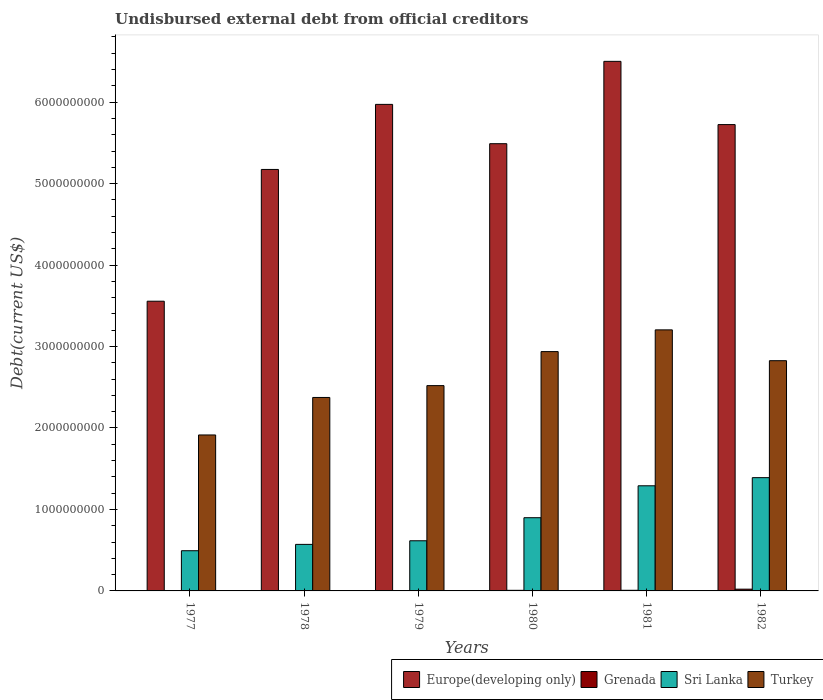How many different coloured bars are there?
Keep it short and to the point. 4. Are the number of bars per tick equal to the number of legend labels?
Make the answer very short. Yes. How many bars are there on the 2nd tick from the left?
Your response must be concise. 4. How many bars are there on the 1st tick from the right?
Your response must be concise. 4. What is the label of the 4th group of bars from the left?
Offer a terse response. 1980. What is the total debt in Grenada in 1979?
Offer a terse response. 1.01e+06. Across all years, what is the maximum total debt in Turkey?
Make the answer very short. 3.20e+09. Across all years, what is the minimum total debt in Europe(developing only)?
Provide a succinct answer. 3.56e+09. In which year was the total debt in Grenada maximum?
Provide a succinct answer. 1982. In which year was the total debt in Europe(developing only) minimum?
Offer a terse response. 1977. What is the total total debt in Europe(developing only) in the graph?
Ensure brevity in your answer.  3.24e+1. What is the difference between the total debt in Turkey in 1978 and that in 1981?
Give a very brief answer. -8.30e+08. What is the difference between the total debt in Grenada in 1981 and the total debt in Turkey in 1982?
Offer a very short reply. -2.82e+09. What is the average total debt in Sri Lanka per year?
Offer a very short reply. 8.77e+08. In the year 1982, what is the difference between the total debt in Turkey and total debt in Europe(developing only)?
Your answer should be compact. -2.90e+09. In how many years, is the total debt in Europe(developing only) greater than 6000000000 US$?
Ensure brevity in your answer.  1. What is the ratio of the total debt in Sri Lanka in 1978 to that in 1982?
Your response must be concise. 0.41. Is the total debt in Sri Lanka in 1978 less than that in 1981?
Keep it short and to the point. Yes. What is the difference between the highest and the second highest total debt in Grenada?
Your answer should be compact. 1.38e+07. What is the difference between the highest and the lowest total debt in Turkey?
Provide a succinct answer. 1.29e+09. In how many years, is the total debt in Sri Lanka greater than the average total debt in Sri Lanka taken over all years?
Provide a succinct answer. 3. Is the sum of the total debt in Sri Lanka in 1977 and 1980 greater than the maximum total debt in Turkey across all years?
Your answer should be very brief. No. What does the 1st bar from the left in 1977 represents?
Offer a very short reply. Europe(developing only). What does the 1st bar from the right in 1977 represents?
Your response must be concise. Turkey. How many bars are there?
Provide a succinct answer. 24. Are all the bars in the graph horizontal?
Your answer should be compact. No. What is the difference between two consecutive major ticks on the Y-axis?
Give a very brief answer. 1.00e+09. Does the graph contain any zero values?
Provide a short and direct response. No. How many legend labels are there?
Ensure brevity in your answer.  4. What is the title of the graph?
Your answer should be compact. Undisbursed external debt from official creditors. What is the label or title of the X-axis?
Offer a terse response. Years. What is the label or title of the Y-axis?
Your answer should be compact. Debt(current US$). What is the Debt(current US$) in Europe(developing only) in 1977?
Give a very brief answer. 3.56e+09. What is the Debt(current US$) in Grenada in 1977?
Make the answer very short. 4.44e+06. What is the Debt(current US$) of Sri Lanka in 1977?
Give a very brief answer. 4.93e+08. What is the Debt(current US$) in Turkey in 1977?
Offer a terse response. 1.91e+09. What is the Debt(current US$) of Europe(developing only) in 1978?
Keep it short and to the point. 5.17e+09. What is the Debt(current US$) of Grenada in 1978?
Offer a terse response. 1.91e+06. What is the Debt(current US$) in Sri Lanka in 1978?
Offer a terse response. 5.71e+08. What is the Debt(current US$) of Turkey in 1978?
Provide a succinct answer. 2.37e+09. What is the Debt(current US$) of Europe(developing only) in 1979?
Offer a very short reply. 5.97e+09. What is the Debt(current US$) in Grenada in 1979?
Provide a short and direct response. 1.01e+06. What is the Debt(current US$) in Sri Lanka in 1979?
Ensure brevity in your answer.  6.16e+08. What is the Debt(current US$) of Turkey in 1979?
Ensure brevity in your answer.  2.52e+09. What is the Debt(current US$) of Europe(developing only) in 1980?
Make the answer very short. 5.49e+09. What is the Debt(current US$) of Grenada in 1980?
Offer a very short reply. 7.29e+06. What is the Debt(current US$) of Sri Lanka in 1980?
Give a very brief answer. 8.99e+08. What is the Debt(current US$) in Turkey in 1980?
Ensure brevity in your answer.  2.94e+09. What is the Debt(current US$) of Europe(developing only) in 1981?
Your answer should be very brief. 6.50e+09. What is the Debt(current US$) of Grenada in 1981?
Provide a succinct answer. 7.84e+06. What is the Debt(current US$) in Sri Lanka in 1981?
Offer a terse response. 1.29e+09. What is the Debt(current US$) in Turkey in 1981?
Give a very brief answer. 3.20e+09. What is the Debt(current US$) of Europe(developing only) in 1982?
Give a very brief answer. 5.72e+09. What is the Debt(current US$) of Grenada in 1982?
Offer a terse response. 2.16e+07. What is the Debt(current US$) in Sri Lanka in 1982?
Offer a terse response. 1.39e+09. What is the Debt(current US$) in Turkey in 1982?
Your answer should be very brief. 2.83e+09. Across all years, what is the maximum Debt(current US$) of Europe(developing only)?
Your response must be concise. 6.50e+09. Across all years, what is the maximum Debt(current US$) of Grenada?
Offer a terse response. 2.16e+07. Across all years, what is the maximum Debt(current US$) in Sri Lanka?
Your answer should be compact. 1.39e+09. Across all years, what is the maximum Debt(current US$) of Turkey?
Provide a succinct answer. 3.20e+09. Across all years, what is the minimum Debt(current US$) in Europe(developing only)?
Your answer should be compact. 3.56e+09. Across all years, what is the minimum Debt(current US$) of Grenada?
Your response must be concise. 1.01e+06. Across all years, what is the minimum Debt(current US$) of Sri Lanka?
Give a very brief answer. 4.93e+08. Across all years, what is the minimum Debt(current US$) in Turkey?
Provide a short and direct response. 1.91e+09. What is the total Debt(current US$) in Europe(developing only) in the graph?
Give a very brief answer. 3.24e+1. What is the total Debt(current US$) in Grenada in the graph?
Your response must be concise. 4.41e+07. What is the total Debt(current US$) in Sri Lanka in the graph?
Keep it short and to the point. 5.26e+09. What is the total Debt(current US$) of Turkey in the graph?
Ensure brevity in your answer.  1.58e+1. What is the difference between the Debt(current US$) in Europe(developing only) in 1977 and that in 1978?
Make the answer very short. -1.62e+09. What is the difference between the Debt(current US$) in Grenada in 1977 and that in 1978?
Keep it short and to the point. 2.53e+06. What is the difference between the Debt(current US$) in Sri Lanka in 1977 and that in 1978?
Ensure brevity in your answer.  -7.78e+07. What is the difference between the Debt(current US$) in Turkey in 1977 and that in 1978?
Your answer should be compact. -4.60e+08. What is the difference between the Debt(current US$) of Europe(developing only) in 1977 and that in 1979?
Make the answer very short. -2.42e+09. What is the difference between the Debt(current US$) in Grenada in 1977 and that in 1979?
Provide a succinct answer. 3.43e+06. What is the difference between the Debt(current US$) in Sri Lanka in 1977 and that in 1979?
Your response must be concise. -1.22e+08. What is the difference between the Debt(current US$) of Turkey in 1977 and that in 1979?
Make the answer very short. -6.06e+08. What is the difference between the Debt(current US$) in Europe(developing only) in 1977 and that in 1980?
Make the answer very short. -1.93e+09. What is the difference between the Debt(current US$) of Grenada in 1977 and that in 1980?
Make the answer very short. -2.85e+06. What is the difference between the Debt(current US$) in Sri Lanka in 1977 and that in 1980?
Give a very brief answer. -4.05e+08. What is the difference between the Debt(current US$) in Turkey in 1977 and that in 1980?
Offer a very short reply. -1.02e+09. What is the difference between the Debt(current US$) in Europe(developing only) in 1977 and that in 1981?
Provide a succinct answer. -2.94e+09. What is the difference between the Debt(current US$) in Grenada in 1977 and that in 1981?
Your response must be concise. -3.40e+06. What is the difference between the Debt(current US$) in Sri Lanka in 1977 and that in 1981?
Your answer should be very brief. -7.97e+08. What is the difference between the Debt(current US$) of Turkey in 1977 and that in 1981?
Keep it short and to the point. -1.29e+09. What is the difference between the Debt(current US$) in Europe(developing only) in 1977 and that in 1982?
Your answer should be very brief. -2.17e+09. What is the difference between the Debt(current US$) of Grenada in 1977 and that in 1982?
Give a very brief answer. -1.72e+07. What is the difference between the Debt(current US$) in Sri Lanka in 1977 and that in 1982?
Offer a terse response. -8.97e+08. What is the difference between the Debt(current US$) of Turkey in 1977 and that in 1982?
Make the answer very short. -9.12e+08. What is the difference between the Debt(current US$) of Europe(developing only) in 1978 and that in 1979?
Your answer should be very brief. -7.99e+08. What is the difference between the Debt(current US$) in Grenada in 1978 and that in 1979?
Your answer should be very brief. 9.03e+05. What is the difference between the Debt(current US$) in Sri Lanka in 1978 and that in 1979?
Provide a succinct answer. -4.44e+07. What is the difference between the Debt(current US$) of Turkey in 1978 and that in 1979?
Ensure brevity in your answer.  -1.46e+08. What is the difference between the Debt(current US$) in Europe(developing only) in 1978 and that in 1980?
Give a very brief answer. -3.16e+08. What is the difference between the Debt(current US$) in Grenada in 1978 and that in 1980?
Give a very brief answer. -5.38e+06. What is the difference between the Debt(current US$) of Sri Lanka in 1978 and that in 1980?
Provide a succinct answer. -3.28e+08. What is the difference between the Debt(current US$) of Turkey in 1978 and that in 1980?
Ensure brevity in your answer.  -5.63e+08. What is the difference between the Debt(current US$) in Europe(developing only) in 1978 and that in 1981?
Keep it short and to the point. -1.33e+09. What is the difference between the Debt(current US$) in Grenada in 1978 and that in 1981?
Ensure brevity in your answer.  -5.92e+06. What is the difference between the Debt(current US$) in Sri Lanka in 1978 and that in 1981?
Your response must be concise. -7.19e+08. What is the difference between the Debt(current US$) of Turkey in 1978 and that in 1981?
Provide a succinct answer. -8.30e+08. What is the difference between the Debt(current US$) of Europe(developing only) in 1978 and that in 1982?
Ensure brevity in your answer.  -5.51e+08. What is the difference between the Debt(current US$) in Grenada in 1978 and that in 1982?
Your answer should be very brief. -1.97e+07. What is the difference between the Debt(current US$) in Sri Lanka in 1978 and that in 1982?
Offer a terse response. -8.19e+08. What is the difference between the Debt(current US$) of Turkey in 1978 and that in 1982?
Give a very brief answer. -4.52e+08. What is the difference between the Debt(current US$) of Europe(developing only) in 1979 and that in 1980?
Ensure brevity in your answer.  4.83e+08. What is the difference between the Debt(current US$) of Grenada in 1979 and that in 1980?
Your answer should be compact. -6.28e+06. What is the difference between the Debt(current US$) in Sri Lanka in 1979 and that in 1980?
Make the answer very short. -2.83e+08. What is the difference between the Debt(current US$) in Turkey in 1979 and that in 1980?
Your response must be concise. -4.18e+08. What is the difference between the Debt(current US$) of Europe(developing only) in 1979 and that in 1981?
Offer a very short reply. -5.28e+08. What is the difference between the Debt(current US$) in Grenada in 1979 and that in 1981?
Make the answer very short. -6.83e+06. What is the difference between the Debt(current US$) of Sri Lanka in 1979 and that in 1981?
Make the answer very short. -6.75e+08. What is the difference between the Debt(current US$) of Turkey in 1979 and that in 1981?
Your answer should be compact. -6.84e+08. What is the difference between the Debt(current US$) in Europe(developing only) in 1979 and that in 1982?
Offer a terse response. 2.48e+08. What is the difference between the Debt(current US$) in Grenada in 1979 and that in 1982?
Provide a succinct answer. -2.06e+07. What is the difference between the Debt(current US$) in Sri Lanka in 1979 and that in 1982?
Your answer should be compact. -7.75e+08. What is the difference between the Debt(current US$) in Turkey in 1979 and that in 1982?
Make the answer very short. -3.06e+08. What is the difference between the Debt(current US$) in Europe(developing only) in 1980 and that in 1981?
Your response must be concise. -1.01e+09. What is the difference between the Debt(current US$) of Grenada in 1980 and that in 1981?
Ensure brevity in your answer.  -5.47e+05. What is the difference between the Debt(current US$) of Sri Lanka in 1980 and that in 1981?
Your response must be concise. -3.92e+08. What is the difference between the Debt(current US$) of Turkey in 1980 and that in 1981?
Your answer should be very brief. -2.67e+08. What is the difference between the Debt(current US$) of Europe(developing only) in 1980 and that in 1982?
Your response must be concise. -2.35e+08. What is the difference between the Debt(current US$) of Grenada in 1980 and that in 1982?
Give a very brief answer. -1.43e+07. What is the difference between the Debt(current US$) in Sri Lanka in 1980 and that in 1982?
Your answer should be very brief. -4.92e+08. What is the difference between the Debt(current US$) in Turkey in 1980 and that in 1982?
Offer a terse response. 1.12e+08. What is the difference between the Debt(current US$) of Europe(developing only) in 1981 and that in 1982?
Provide a short and direct response. 7.76e+08. What is the difference between the Debt(current US$) of Grenada in 1981 and that in 1982?
Keep it short and to the point. -1.38e+07. What is the difference between the Debt(current US$) of Sri Lanka in 1981 and that in 1982?
Keep it short and to the point. -9.99e+07. What is the difference between the Debt(current US$) in Turkey in 1981 and that in 1982?
Your response must be concise. 3.78e+08. What is the difference between the Debt(current US$) in Europe(developing only) in 1977 and the Debt(current US$) in Grenada in 1978?
Provide a succinct answer. 3.55e+09. What is the difference between the Debt(current US$) in Europe(developing only) in 1977 and the Debt(current US$) in Sri Lanka in 1978?
Ensure brevity in your answer.  2.99e+09. What is the difference between the Debt(current US$) in Europe(developing only) in 1977 and the Debt(current US$) in Turkey in 1978?
Keep it short and to the point. 1.18e+09. What is the difference between the Debt(current US$) of Grenada in 1977 and the Debt(current US$) of Sri Lanka in 1978?
Ensure brevity in your answer.  -5.67e+08. What is the difference between the Debt(current US$) of Grenada in 1977 and the Debt(current US$) of Turkey in 1978?
Your answer should be compact. -2.37e+09. What is the difference between the Debt(current US$) in Sri Lanka in 1977 and the Debt(current US$) in Turkey in 1978?
Your answer should be compact. -1.88e+09. What is the difference between the Debt(current US$) of Europe(developing only) in 1977 and the Debt(current US$) of Grenada in 1979?
Your answer should be compact. 3.56e+09. What is the difference between the Debt(current US$) of Europe(developing only) in 1977 and the Debt(current US$) of Sri Lanka in 1979?
Make the answer very short. 2.94e+09. What is the difference between the Debt(current US$) of Europe(developing only) in 1977 and the Debt(current US$) of Turkey in 1979?
Give a very brief answer. 1.04e+09. What is the difference between the Debt(current US$) of Grenada in 1977 and the Debt(current US$) of Sri Lanka in 1979?
Offer a very short reply. -6.11e+08. What is the difference between the Debt(current US$) in Grenada in 1977 and the Debt(current US$) in Turkey in 1979?
Your answer should be very brief. -2.52e+09. What is the difference between the Debt(current US$) in Sri Lanka in 1977 and the Debt(current US$) in Turkey in 1979?
Keep it short and to the point. -2.03e+09. What is the difference between the Debt(current US$) in Europe(developing only) in 1977 and the Debt(current US$) in Grenada in 1980?
Keep it short and to the point. 3.55e+09. What is the difference between the Debt(current US$) in Europe(developing only) in 1977 and the Debt(current US$) in Sri Lanka in 1980?
Your response must be concise. 2.66e+09. What is the difference between the Debt(current US$) of Europe(developing only) in 1977 and the Debt(current US$) of Turkey in 1980?
Give a very brief answer. 6.19e+08. What is the difference between the Debt(current US$) in Grenada in 1977 and the Debt(current US$) in Sri Lanka in 1980?
Give a very brief answer. -8.94e+08. What is the difference between the Debt(current US$) of Grenada in 1977 and the Debt(current US$) of Turkey in 1980?
Your response must be concise. -2.93e+09. What is the difference between the Debt(current US$) of Sri Lanka in 1977 and the Debt(current US$) of Turkey in 1980?
Your answer should be compact. -2.44e+09. What is the difference between the Debt(current US$) of Europe(developing only) in 1977 and the Debt(current US$) of Grenada in 1981?
Offer a very short reply. 3.55e+09. What is the difference between the Debt(current US$) in Europe(developing only) in 1977 and the Debt(current US$) in Sri Lanka in 1981?
Your response must be concise. 2.27e+09. What is the difference between the Debt(current US$) in Europe(developing only) in 1977 and the Debt(current US$) in Turkey in 1981?
Ensure brevity in your answer.  3.52e+08. What is the difference between the Debt(current US$) of Grenada in 1977 and the Debt(current US$) of Sri Lanka in 1981?
Offer a very short reply. -1.29e+09. What is the difference between the Debt(current US$) of Grenada in 1977 and the Debt(current US$) of Turkey in 1981?
Offer a very short reply. -3.20e+09. What is the difference between the Debt(current US$) of Sri Lanka in 1977 and the Debt(current US$) of Turkey in 1981?
Offer a very short reply. -2.71e+09. What is the difference between the Debt(current US$) in Europe(developing only) in 1977 and the Debt(current US$) in Grenada in 1982?
Offer a very short reply. 3.53e+09. What is the difference between the Debt(current US$) in Europe(developing only) in 1977 and the Debt(current US$) in Sri Lanka in 1982?
Your response must be concise. 2.17e+09. What is the difference between the Debt(current US$) in Europe(developing only) in 1977 and the Debt(current US$) in Turkey in 1982?
Your answer should be compact. 7.30e+08. What is the difference between the Debt(current US$) of Grenada in 1977 and the Debt(current US$) of Sri Lanka in 1982?
Keep it short and to the point. -1.39e+09. What is the difference between the Debt(current US$) in Grenada in 1977 and the Debt(current US$) in Turkey in 1982?
Give a very brief answer. -2.82e+09. What is the difference between the Debt(current US$) of Sri Lanka in 1977 and the Debt(current US$) of Turkey in 1982?
Offer a very short reply. -2.33e+09. What is the difference between the Debt(current US$) of Europe(developing only) in 1978 and the Debt(current US$) of Grenada in 1979?
Keep it short and to the point. 5.17e+09. What is the difference between the Debt(current US$) of Europe(developing only) in 1978 and the Debt(current US$) of Sri Lanka in 1979?
Make the answer very short. 4.56e+09. What is the difference between the Debt(current US$) of Europe(developing only) in 1978 and the Debt(current US$) of Turkey in 1979?
Give a very brief answer. 2.65e+09. What is the difference between the Debt(current US$) in Grenada in 1978 and the Debt(current US$) in Sri Lanka in 1979?
Your response must be concise. -6.14e+08. What is the difference between the Debt(current US$) of Grenada in 1978 and the Debt(current US$) of Turkey in 1979?
Provide a succinct answer. -2.52e+09. What is the difference between the Debt(current US$) of Sri Lanka in 1978 and the Debt(current US$) of Turkey in 1979?
Offer a very short reply. -1.95e+09. What is the difference between the Debt(current US$) in Europe(developing only) in 1978 and the Debt(current US$) in Grenada in 1980?
Your answer should be very brief. 5.17e+09. What is the difference between the Debt(current US$) in Europe(developing only) in 1978 and the Debt(current US$) in Sri Lanka in 1980?
Offer a very short reply. 4.28e+09. What is the difference between the Debt(current US$) of Europe(developing only) in 1978 and the Debt(current US$) of Turkey in 1980?
Offer a terse response. 2.24e+09. What is the difference between the Debt(current US$) in Grenada in 1978 and the Debt(current US$) in Sri Lanka in 1980?
Give a very brief answer. -8.97e+08. What is the difference between the Debt(current US$) in Grenada in 1978 and the Debt(current US$) in Turkey in 1980?
Provide a short and direct response. -2.94e+09. What is the difference between the Debt(current US$) in Sri Lanka in 1978 and the Debt(current US$) in Turkey in 1980?
Offer a very short reply. -2.37e+09. What is the difference between the Debt(current US$) in Europe(developing only) in 1978 and the Debt(current US$) in Grenada in 1981?
Keep it short and to the point. 5.17e+09. What is the difference between the Debt(current US$) of Europe(developing only) in 1978 and the Debt(current US$) of Sri Lanka in 1981?
Ensure brevity in your answer.  3.88e+09. What is the difference between the Debt(current US$) of Europe(developing only) in 1978 and the Debt(current US$) of Turkey in 1981?
Your answer should be compact. 1.97e+09. What is the difference between the Debt(current US$) in Grenada in 1978 and the Debt(current US$) in Sri Lanka in 1981?
Make the answer very short. -1.29e+09. What is the difference between the Debt(current US$) in Grenada in 1978 and the Debt(current US$) in Turkey in 1981?
Your answer should be compact. -3.20e+09. What is the difference between the Debt(current US$) in Sri Lanka in 1978 and the Debt(current US$) in Turkey in 1981?
Offer a very short reply. -2.63e+09. What is the difference between the Debt(current US$) in Europe(developing only) in 1978 and the Debt(current US$) in Grenada in 1982?
Offer a very short reply. 5.15e+09. What is the difference between the Debt(current US$) in Europe(developing only) in 1978 and the Debt(current US$) in Sri Lanka in 1982?
Provide a short and direct response. 3.78e+09. What is the difference between the Debt(current US$) of Europe(developing only) in 1978 and the Debt(current US$) of Turkey in 1982?
Your answer should be very brief. 2.35e+09. What is the difference between the Debt(current US$) in Grenada in 1978 and the Debt(current US$) in Sri Lanka in 1982?
Ensure brevity in your answer.  -1.39e+09. What is the difference between the Debt(current US$) in Grenada in 1978 and the Debt(current US$) in Turkey in 1982?
Provide a succinct answer. -2.82e+09. What is the difference between the Debt(current US$) in Sri Lanka in 1978 and the Debt(current US$) in Turkey in 1982?
Your response must be concise. -2.26e+09. What is the difference between the Debt(current US$) of Europe(developing only) in 1979 and the Debt(current US$) of Grenada in 1980?
Make the answer very short. 5.97e+09. What is the difference between the Debt(current US$) of Europe(developing only) in 1979 and the Debt(current US$) of Sri Lanka in 1980?
Keep it short and to the point. 5.07e+09. What is the difference between the Debt(current US$) in Europe(developing only) in 1979 and the Debt(current US$) in Turkey in 1980?
Provide a short and direct response. 3.03e+09. What is the difference between the Debt(current US$) of Grenada in 1979 and the Debt(current US$) of Sri Lanka in 1980?
Make the answer very short. -8.98e+08. What is the difference between the Debt(current US$) of Grenada in 1979 and the Debt(current US$) of Turkey in 1980?
Your answer should be very brief. -2.94e+09. What is the difference between the Debt(current US$) of Sri Lanka in 1979 and the Debt(current US$) of Turkey in 1980?
Keep it short and to the point. -2.32e+09. What is the difference between the Debt(current US$) of Europe(developing only) in 1979 and the Debt(current US$) of Grenada in 1981?
Keep it short and to the point. 5.96e+09. What is the difference between the Debt(current US$) of Europe(developing only) in 1979 and the Debt(current US$) of Sri Lanka in 1981?
Make the answer very short. 4.68e+09. What is the difference between the Debt(current US$) of Europe(developing only) in 1979 and the Debt(current US$) of Turkey in 1981?
Give a very brief answer. 2.77e+09. What is the difference between the Debt(current US$) in Grenada in 1979 and the Debt(current US$) in Sri Lanka in 1981?
Offer a terse response. -1.29e+09. What is the difference between the Debt(current US$) in Grenada in 1979 and the Debt(current US$) in Turkey in 1981?
Make the answer very short. -3.20e+09. What is the difference between the Debt(current US$) of Sri Lanka in 1979 and the Debt(current US$) of Turkey in 1981?
Your response must be concise. -2.59e+09. What is the difference between the Debt(current US$) in Europe(developing only) in 1979 and the Debt(current US$) in Grenada in 1982?
Give a very brief answer. 5.95e+09. What is the difference between the Debt(current US$) of Europe(developing only) in 1979 and the Debt(current US$) of Sri Lanka in 1982?
Offer a very short reply. 4.58e+09. What is the difference between the Debt(current US$) of Europe(developing only) in 1979 and the Debt(current US$) of Turkey in 1982?
Your answer should be compact. 3.15e+09. What is the difference between the Debt(current US$) of Grenada in 1979 and the Debt(current US$) of Sri Lanka in 1982?
Make the answer very short. -1.39e+09. What is the difference between the Debt(current US$) in Grenada in 1979 and the Debt(current US$) in Turkey in 1982?
Make the answer very short. -2.83e+09. What is the difference between the Debt(current US$) in Sri Lanka in 1979 and the Debt(current US$) in Turkey in 1982?
Ensure brevity in your answer.  -2.21e+09. What is the difference between the Debt(current US$) of Europe(developing only) in 1980 and the Debt(current US$) of Grenada in 1981?
Provide a succinct answer. 5.48e+09. What is the difference between the Debt(current US$) of Europe(developing only) in 1980 and the Debt(current US$) of Sri Lanka in 1981?
Give a very brief answer. 4.20e+09. What is the difference between the Debt(current US$) of Europe(developing only) in 1980 and the Debt(current US$) of Turkey in 1981?
Make the answer very short. 2.29e+09. What is the difference between the Debt(current US$) in Grenada in 1980 and the Debt(current US$) in Sri Lanka in 1981?
Provide a short and direct response. -1.28e+09. What is the difference between the Debt(current US$) of Grenada in 1980 and the Debt(current US$) of Turkey in 1981?
Provide a short and direct response. -3.20e+09. What is the difference between the Debt(current US$) of Sri Lanka in 1980 and the Debt(current US$) of Turkey in 1981?
Provide a short and direct response. -2.31e+09. What is the difference between the Debt(current US$) in Europe(developing only) in 1980 and the Debt(current US$) in Grenada in 1982?
Keep it short and to the point. 5.47e+09. What is the difference between the Debt(current US$) in Europe(developing only) in 1980 and the Debt(current US$) in Sri Lanka in 1982?
Keep it short and to the point. 4.10e+09. What is the difference between the Debt(current US$) in Europe(developing only) in 1980 and the Debt(current US$) in Turkey in 1982?
Make the answer very short. 2.66e+09. What is the difference between the Debt(current US$) of Grenada in 1980 and the Debt(current US$) of Sri Lanka in 1982?
Provide a short and direct response. -1.38e+09. What is the difference between the Debt(current US$) in Grenada in 1980 and the Debt(current US$) in Turkey in 1982?
Keep it short and to the point. -2.82e+09. What is the difference between the Debt(current US$) in Sri Lanka in 1980 and the Debt(current US$) in Turkey in 1982?
Provide a succinct answer. -1.93e+09. What is the difference between the Debt(current US$) of Europe(developing only) in 1981 and the Debt(current US$) of Grenada in 1982?
Keep it short and to the point. 6.48e+09. What is the difference between the Debt(current US$) of Europe(developing only) in 1981 and the Debt(current US$) of Sri Lanka in 1982?
Offer a very short reply. 5.11e+09. What is the difference between the Debt(current US$) of Europe(developing only) in 1981 and the Debt(current US$) of Turkey in 1982?
Provide a short and direct response. 3.67e+09. What is the difference between the Debt(current US$) in Grenada in 1981 and the Debt(current US$) in Sri Lanka in 1982?
Keep it short and to the point. -1.38e+09. What is the difference between the Debt(current US$) in Grenada in 1981 and the Debt(current US$) in Turkey in 1982?
Keep it short and to the point. -2.82e+09. What is the difference between the Debt(current US$) of Sri Lanka in 1981 and the Debt(current US$) of Turkey in 1982?
Ensure brevity in your answer.  -1.54e+09. What is the average Debt(current US$) in Europe(developing only) per year?
Give a very brief answer. 5.40e+09. What is the average Debt(current US$) of Grenada per year?
Provide a succinct answer. 7.35e+06. What is the average Debt(current US$) of Sri Lanka per year?
Ensure brevity in your answer.  8.77e+08. What is the average Debt(current US$) of Turkey per year?
Your response must be concise. 2.63e+09. In the year 1977, what is the difference between the Debt(current US$) in Europe(developing only) and Debt(current US$) in Grenada?
Provide a short and direct response. 3.55e+09. In the year 1977, what is the difference between the Debt(current US$) of Europe(developing only) and Debt(current US$) of Sri Lanka?
Offer a terse response. 3.06e+09. In the year 1977, what is the difference between the Debt(current US$) of Europe(developing only) and Debt(current US$) of Turkey?
Make the answer very short. 1.64e+09. In the year 1977, what is the difference between the Debt(current US$) of Grenada and Debt(current US$) of Sri Lanka?
Provide a short and direct response. -4.89e+08. In the year 1977, what is the difference between the Debt(current US$) in Grenada and Debt(current US$) in Turkey?
Give a very brief answer. -1.91e+09. In the year 1977, what is the difference between the Debt(current US$) in Sri Lanka and Debt(current US$) in Turkey?
Provide a short and direct response. -1.42e+09. In the year 1978, what is the difference between the Debt(current US$) of Europe(developing only) and Debt(current US$) of Grenada?
Make the answer very short. 5.17e+09. In the year 1978, what is the difference between the Debt(current US$) in Europe(developing only) and Debt(current US$) in Sri Lanka?
Ensure brevity in your answer.  4.60e+09. In the year 1978, what is the difference between the Debt(current US$) in Europe(developing only) and Debt(current US$) in Turkey?
Offer a terse response. 2.80e+09. In the year 1978, what is the difference between the Debt(current US$) of Grenada and Debt(current US$) of Sri Lanka?
Offer a very short reply. -5.69e+08. In the year 1978, what is the difference between the Debt(current US$) in Grenada and Debt(current US$) in Turkey?
Make the answer very short. -2.37e+09. In the year 1978, what is the difference between the Debt(current US$) in Sri Lanka and Debt(current US$) in Turkey?
Offer a very short reply. -1.80e+09. In the year 1979, what is the difference between the Debt(current US$) in Europe(developing only) and Debt(current US$) in Grenada?
Provide a short and direct response. 5.97e+09. In the year 1979, what is the difference between the Debt(current US$) in Europe(developing only) and Debt(current US$) in Sri Lanka?
Provide a short and direct response. 5.36e+09. In the year 1979, what is the difference between the Debt(current US$) in Europe(developing only) and Debt(current US$) in Turkey?
Provide a succinct answer. 3.45e+09. In the year 1979, what is the difference between the Debt(current US$) in Grenada and Debt(current US$) in Sri Lanka?
Keep it short and to the point. -6.15e+08. In the year 1979, what is the difference between the Debt(current US$) in Grenada and Debt(current US$) in Turkey?
Your answer should be very brief. -2.52e+09. In the year 1979, what is the difference between the Debt(current US$) in Sri Lanka and Debt(current US$) in Turkey?
Your response must be concise. -1.90e+09. In the year 1980, what is the difference between the Debt(current US$) in Europe(developing only) and Debt(current US$) in Grenada?
Keep it short and to the point. 5.48e+09. In the year 1980, what is the difference between the Debt(current US$) in Europe(developing only) and Debt(current US$) in Sri Lanka?
Make the answer very short. 4.59e+09. In the year 1980, what is the difference between the Debt(current US$) in Europe(developing only) and Debt(current US$) in Turkey?
Provide a short and direct response. 2.55e+09. In the year 1980, what is the difference between the Debt(current US$) of Grenada and Debt(current US$) of Sri Lanka?
Provide a short and direct response. -8.91e+08. In the year 1980, what is the difference between the Debt(current US$) of Grenada and Debt(current US$) of Turkey?
Give a very brief answer. -2.93e+09. In the year 1980, what is the difference between the Debt(current US$) of Sri Lanka and Debt(current US$) of Turkey?
Keep it short and to the point. -2.04e+09. In the year 1981, what is the difference between the Debt(current US$) in Europe(developing only) and Debt(current US$) in Grenada?
Your answer should be compact. 6.49e+09. In the year 1981, what is the difference between the Debt(current US$) in Europe(developing only) and Debt(current US$) in Sri Lanka?
Your answer should be very brief. 5.21e+09. In the year 1981, what is the difference between the Debt(current US$) of Europe(developing only) and Debt(current US$) of Turkey?
Provide a succinct answer. 3.30e+09. In the year 1981, what is the difference between the Debt(current US$) of Grenada and Debt(current US$) of Sri Lanka?
Ensure brevity in your answer.  -1.28e+09. In the year 1981, what is the difference between the Debt(current US$) in Grenada and Debt(current US$) in Turkey?
Your answer should be compact. -3.20e+09. In the year 1981, what is the difference between the Debt(current US$) of Sri Lanka and Debt(current US$) of Turkey?
Your answer should be compact. -1.91e+09. In the year 1982, what is the difference between the Debt(current US$) of Europe(developing only) and Debt(current US$) of Grenada?
Offer a very short reply. 5.70e+09. In the year 1982, what is the difference between the Debt(current US$) of Europe(developing only) and Debt(current US$) of Sri Lanka?
Your answer should be compact. 4.33e+09. In the year 1982, what is the difference between the Debt(current US$) in Europe(developing only) and Debt(current US$) in Turkey?
Ensure brevity in your answer.  2.90e+09. In the year 1982, what is the difference between the Debt(current US$) of Grenada and Debt(current US$) of Sri Lanka?
Give a very brief answer. -1.37e+09. In the year 1982, what is the difference between the Debt(current US$) in Grenada and Debt(current US$) in Turkey?
Your answer should be compact. -2.80e+09. In the year 1982, what is the difference between the Debt(current US$) of Sri Lanka and Debt(current US$) of Turkey?
Give a very brief answer. -1.44e+09. What is the ratio of the Debt(current US$) of Europe(developing only) in 1977 to that in 1978?
Ensure brevity in your answer.  0.69. What is the ratio of the Debt(current US$) of Grenada in 1977 to that in 1978?
Keep it short and to the point. 2.32. What is the ratio of the Debt(current US$) of Sri Lanka in 1977 to that in 1978?
Make the answer very short. 0.86. What is the ratio of the Debt(current US$) in Turkey in 1977 to that in 1978?
Your response must be concise. 0.81. What is the ratio of the Debt(current US$) of Europe(developing only) in 1977 to that in 1979?
Provide a succinct answer. 0.6. What is the ratio of the Debt(current US$) of Grenada in 1977 to that in 1979?
Keep it short and to the point. 4.4. What is the ratio of the Debt(current US$) in Sri Lanka in 1977 to that in 1979?
Provide a succinct answer. 0.8. What is the ratio of the Debt(current US$) in Turkey in 1977 to that in 1979?
Give a very brief answer. 0.76. What is the ratio of the Debt(current US$) in Europe(developing only) in 1977 to that in 1980?
Make the answer very short. 0.65. What is the ratio of the Debt(current US$) of Grenada in 1977 to that in 1980?
Provide a succinct answer. 0.61. What is the ratio of the Debt(current US$) of Sri Lanka in 1977 to that in 1980?
Your answer should be compact. 0.55. What is the ratio of the Debt(current US$) in Turkey in 1977 to that in 1980?
Provide a short and direct response. 0.65. What is the ratio of the Debt(current US$) in Europe(developing only) in 1977 to that in 1981?
Your answer should be compact. 0.55. What is the ratio of the Debt(current US$) in Grenada in 1977 to that in 1981?
Give a very brief answer. 0.57. What is the ratio of the Debt(current US$) of Sri Lanka in 1977 to that in 1981?
Your answer should be very brief. 0.38. What is the ratio of the Debt(current US$) in Turkey in 1977 to that in 1981?
Your answer should be compact. 0.6. What is the ratio of the Debt(current US$) of Europe(developing only) in 1977 to that in 1982?
Provide a short and direct response. 0.62. What is the ratio of the Debt(current US$) of Grenada in 1977 to that in 1982?
Give a very brief answer. 0.21. What is the ratio of the Debt(current US$) of Sri Lanka in 1977 to that in 1982?
Give a very brief answer. 0.35. What is the ratio of the Debt(current US$) of Turkey in 1977 to that in 1982?
Your answer should be compact. 0.68. What is the ratio of the Debt(current US$) in Europe(developing only) in 1978 to that in 1979?
Ensure brevity in your answer.  0.87. What is the ratio of the Debt(current US$) in Grenada in 1978 to that in 1979?
Give a very brief answer. 1.89. What is the ratio of the Debt(current US$) in Sri Lanka in 1978 to that in 1979?
Provide a succinct answer. 0.93. What is the ratio of the Debt(current US$) of Turkey in 1978 to that in 1979?
Offer a very short reply. 0.94. What is the ratio of the Debt(current US$) of Europe(developing only) in 1978 to that in 1980?
Offer a terse response. 0.94. What is the ratio of the Debt(current US$) in Grenada in 1978 to that in 1980?
Provide a short and direct response. 0.26. What is the ratio of the Debt(current US$) of Sri Lanka in 1978 to that in 1980?
Your answer should be very brief. 0.64. What is the ratio of the Debt(current US$) in Turkey in 1978 to that in 1980?
Your answer should be compact. 0.81. What is the ratio of the Debt(current US$) in Europe(developing only) in 1978 to that in 1981?
Make the answer very short. 0.8. What is the ratio of the Debt(current US$) of Grenada in 1978 to that in 1981?
Make the answer very short. 0.24. What is the ratio of the Debt(current US$) in Sri Lanka in 1978 to that in 1981?
Give a very brief answer. 0.44. What is the ratio of the Debt(current US$) in Turkey in 1978 to that in 1981?
Make the answer very short. 0.74. What is the ratio of the Debt(current US$) of Europe(developing only) in 1978 to that in 1982?
Offer a very short reply. 0.9. What is the ratio of the Debt(current US$) of Grenada in 1978 to that in 1982?
Your response must be concise. 0.09. What is the ratio of the Debt(current US$) of Sri Lanka in 1978 to that in 1982?
Give a very brief answer. 0.41. What is the ratio of the Debt(current US$) in Turkey in 1978 to that in 1982?
Offer a terse response. 0.84. What is the ratio of the Debt(current US$) of Europe(developing only) in 1979 to that in 1980?
Your answer should be very brief. 1.09. What is the ratio of the Debt(current US$) in Grenada in 1979 to that in 1980?
Offer a very short reply. 0.14. What is the ratio of the Debt(current US$) in Sri Lanka in 1979 to that in 1980?
Your answer should be very brief. 0.69. What is the ratio of the Debt(current US$) of Turkey in 1979 to that in 1980?
Your response must be concise. 0.86. What is the ratio of the Debt(current US$) of Europe(developing only) in 1979 to that in 1981?
Keep it short and to the point. 0.92. What is the ratio of the Debt(current US$) of Grenada in 1979 to that in 1981?
Provide a succinct answer. 0.13. What is the ratio of the Debt(current US$) in Sri Lanka in 1979 to that in 1981?
Offer a terse response. 0.48. What is the ratio of the Debt(current US$) of Turkey in 1979 to that in 1981?
Your answer should be compact. 0.79. What is the ratio of the Debt(current US$) of Europe(developing only) in 1979 to that in 1982?
Provide a succinct answer. 1.04. What is the ratio of the Debt(current US$) of Grenada in 1979 to that in 1982?
Offer a very short reply. 0.05. What is the ratio of the Debt(current US$) of Sri Lanka in 1979 to that in 1982?
Provide a succinct answer. 0.44. What is the ratio of the Debt(current US$) in Turkey in 1979 to that in 1982?
Give a very brief answer. 0.89. What is the ratio of the Debt(current US$) of Europe(developing only) in 1980 to that in 1981?
Offer a very short reply. 0.84. What is the ratio of the Debt(current US$) of Grenada in 1980 to that in 1981?
Make the answer very short. 0.93. What is the ratio of the Debt(current US$) in Sri Lanka in 1980 to that in 1981?
Your answer should be compact. 0.7. What is the ratio of the Debt(current US$) of Turkey in 1980 to that in 1981?
Give a very brief answer. 0.92. What is the ratio of the Debt(current US$) of Grenada in 1980 to that in 1982?
Offer a very short reply. 0.34. What is the ratio of the Debt(current US$) in Sri Lanka in 1980 to that in 1982?
Keep it short and to the point. 0.65. What is the ratio of the Debt(current US$) of Turkey in 1980 to that in 1982?
Your answer should be compact. 1.04. What is the ratio of the Debt(current US$) in Europe(developing only) in 1981 to that in 1982?
Give a very brief answer. 1.14. What is the ratio of the Debt(current US$) of Grenada in 1981 to that in 1982?
Offer a very short reply. 0.36. What is the ratio of the Debt(current US$) of Sri Lanka in 1981 to that in 1982?
Keep it short and to the point. 0.93. What is the ratio of the Debt(current US$) of Turkey in 1981 to that in 1982?
Provide a succinct answer. 1.13. What is the difference between the highest and the second highest Debt(current US$) of Europe(developing only)?
Your answer should be compact. 5.28e+08. What is the difference between the highest and the second highest Debt(current US$) in Grenada?
Offer a very short reply. 1.38e+07. What is the difference between the highest and the second highest Debt(current US$) of Sri Lanka?
Provide a succinct answer. 9.99e+07. What is the difference between the highest and the second highest Debt(current US$) of Turkey?
Your answer should be very brief. 2.67e+08. What is the difference between the highest and the lowest Debt(current US$) in Europe(developing only)?
Ensure brevity in your answer.  2.94e+09. What is the difference between the highest and the lowest Debt(current US$) of Grenada?
Your response must be concise. 2.06e+07. What is the difference between the highest and the lowest Debt(current US$) in Sri Lanka?
Your response must be concise. 8.97e+08. What is the difference between the highest and the lowest Debt(current US$) of Turkey?
Your response must be concise. 1.29e+09. 